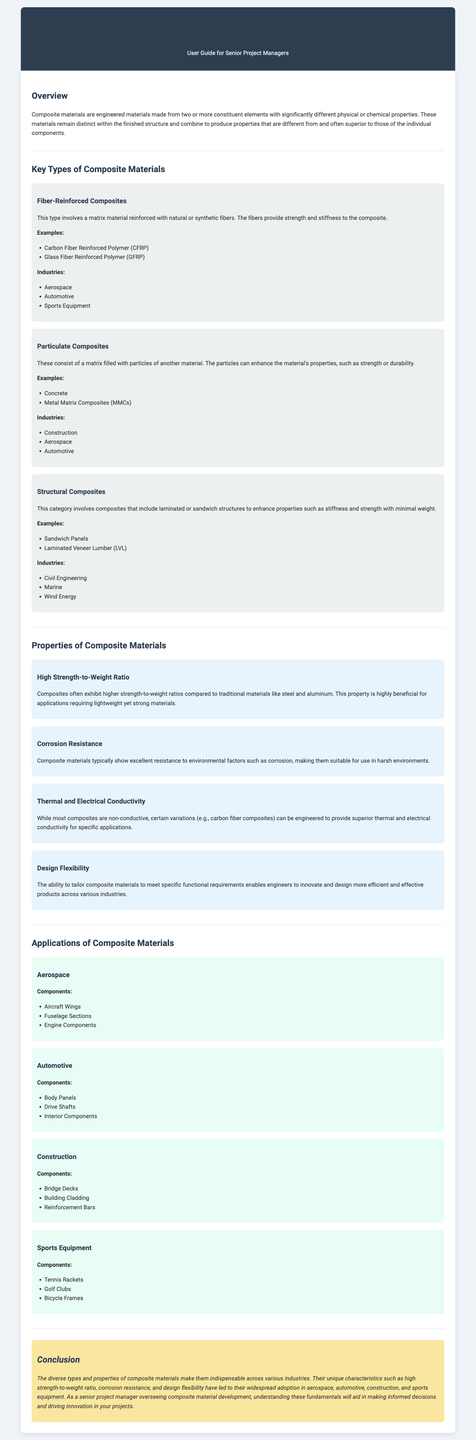What is the main focus of the document? The document provides an overview of composite materials, including their types, properties, and applications.
Answer: Composite materials How many key types of composite materials are mentioned? There are three key types of composite materials listed in the document.
Answer: Three Which type of composite involves a matrix material reinforced with fibers? The type that involves a matrix material reinforced with fibers is known as Fiber-Reinforced Composites.
Answer: Fiber-Reinforced Composites What property of composite materials is highlighted for its benefit in design? The property highlighted for its benefit in design is Design Flexibility.
Answer: Design Flexibility List one application of composite materials in the automotive industry. The document lists Body Panels as one application of composite materials in the automotive industry.
Answer: Body Panels What is a notable property of composite materials in relation to traditional materials? A notable property is the High Strength-to-Weight Ratio compared to traditional materials like steel and aluminum.
Answer: High Strength-to-Weight Ratio Which industry uses Sandwich Panels as a component? The industry that uses Sandwich Panels is Civil Engineering.
Answer: Civil Engineering What is emphasized as a conclusion regarding the use of composite materials? The conclusion emphasizes that composite materials are indispensable across various industries due to their unique characteristics.
Answer: Indispensable across various industries 